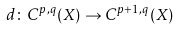Convert formula to latex. <formula><loc_0><loc_0><loc_500><loc_500>d \colon C ^ { p , q } ( X ) \to C ^ { p + 1 , q } ( X )</formula> 